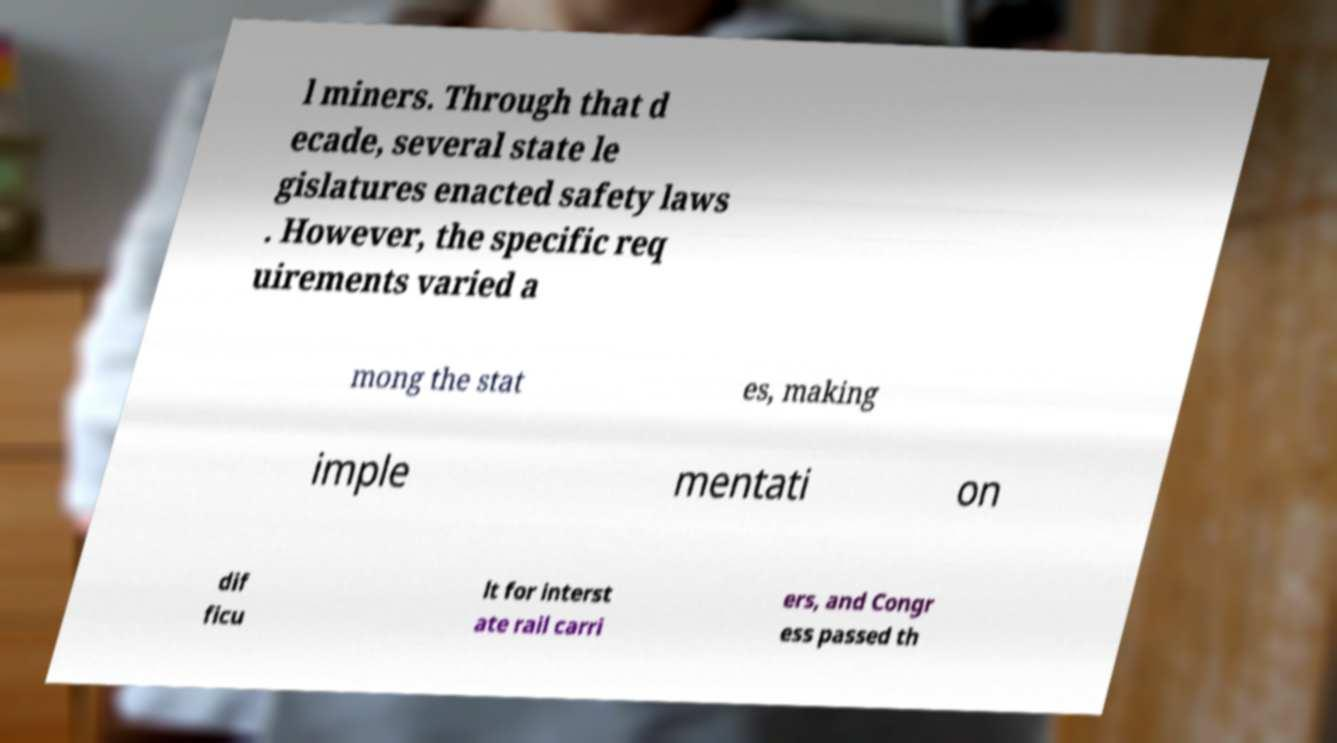Could you assist in decoding the text presented in this image and type it out clearly? l miners. Through that d ecade, several state le gislatures enacted safety laws . However, the specific req uirements varied a mong the stat es, making imple mentati on dif ficu lt for interst ate rail carri ers, and Congr ess passed th 